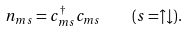<formula> <loc_0><loc_0><loc_500><loc_500>n _ { m s } = c _ { m s } ^ { \dagger } c _ { m s } \quad ( s = \uparrow \downarrow ) .</formula> 